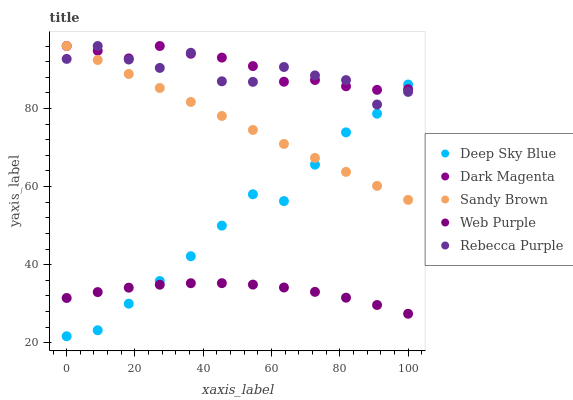Does Web Purple have the minimum area under the curve?
Answer yes or no. Yes. Does Dark Magenta have the maximum area under the curve?
Answer yes or no. Yes. Does Sandy Brown have the minimum area under the curve?
Answer yes or no. No. Does Sandy Brown have the maximum area under the curve?
Answer yes or no. No. Is Sandy Brown the smoothest?
Answer yes or no. Yes. Is Rebecca Purple the roughest?
Answer yes or no. Yes. Is Dark Magenta the smoothest?
Answer yes or no. No. Is Dark Magenta the roughest?
Answer yes or no. No. Does Deep Sky Blue have the lowest value?
Answer yes or no. Yes. Does Sandy Brown have the lowest value?
Answer yes or no. No. Does Rebecca Purple have the highest value?
Answer yes or no. Yes. Does Deep Sky Blue have the highest value?
Answer yes or no. No. Is Web Purple less than Rebecca Purple?
Answer yes or no. Yes. Is Rebecca Purple greater than Web Purple?
Answer yes or no. Yes. Does Rebecca Purple intersect Deep Sky Blue?
Answer yes or no. Yes. Is Rebecca Purple less than Deep Sky Blue?
Answer yes or no. No. Is Rebecca Purple greater than Deep Sky Blue?
Answer yes or no. No. Does Web Purple intersect Rebecca Purple?
Answer yes or no. No. 